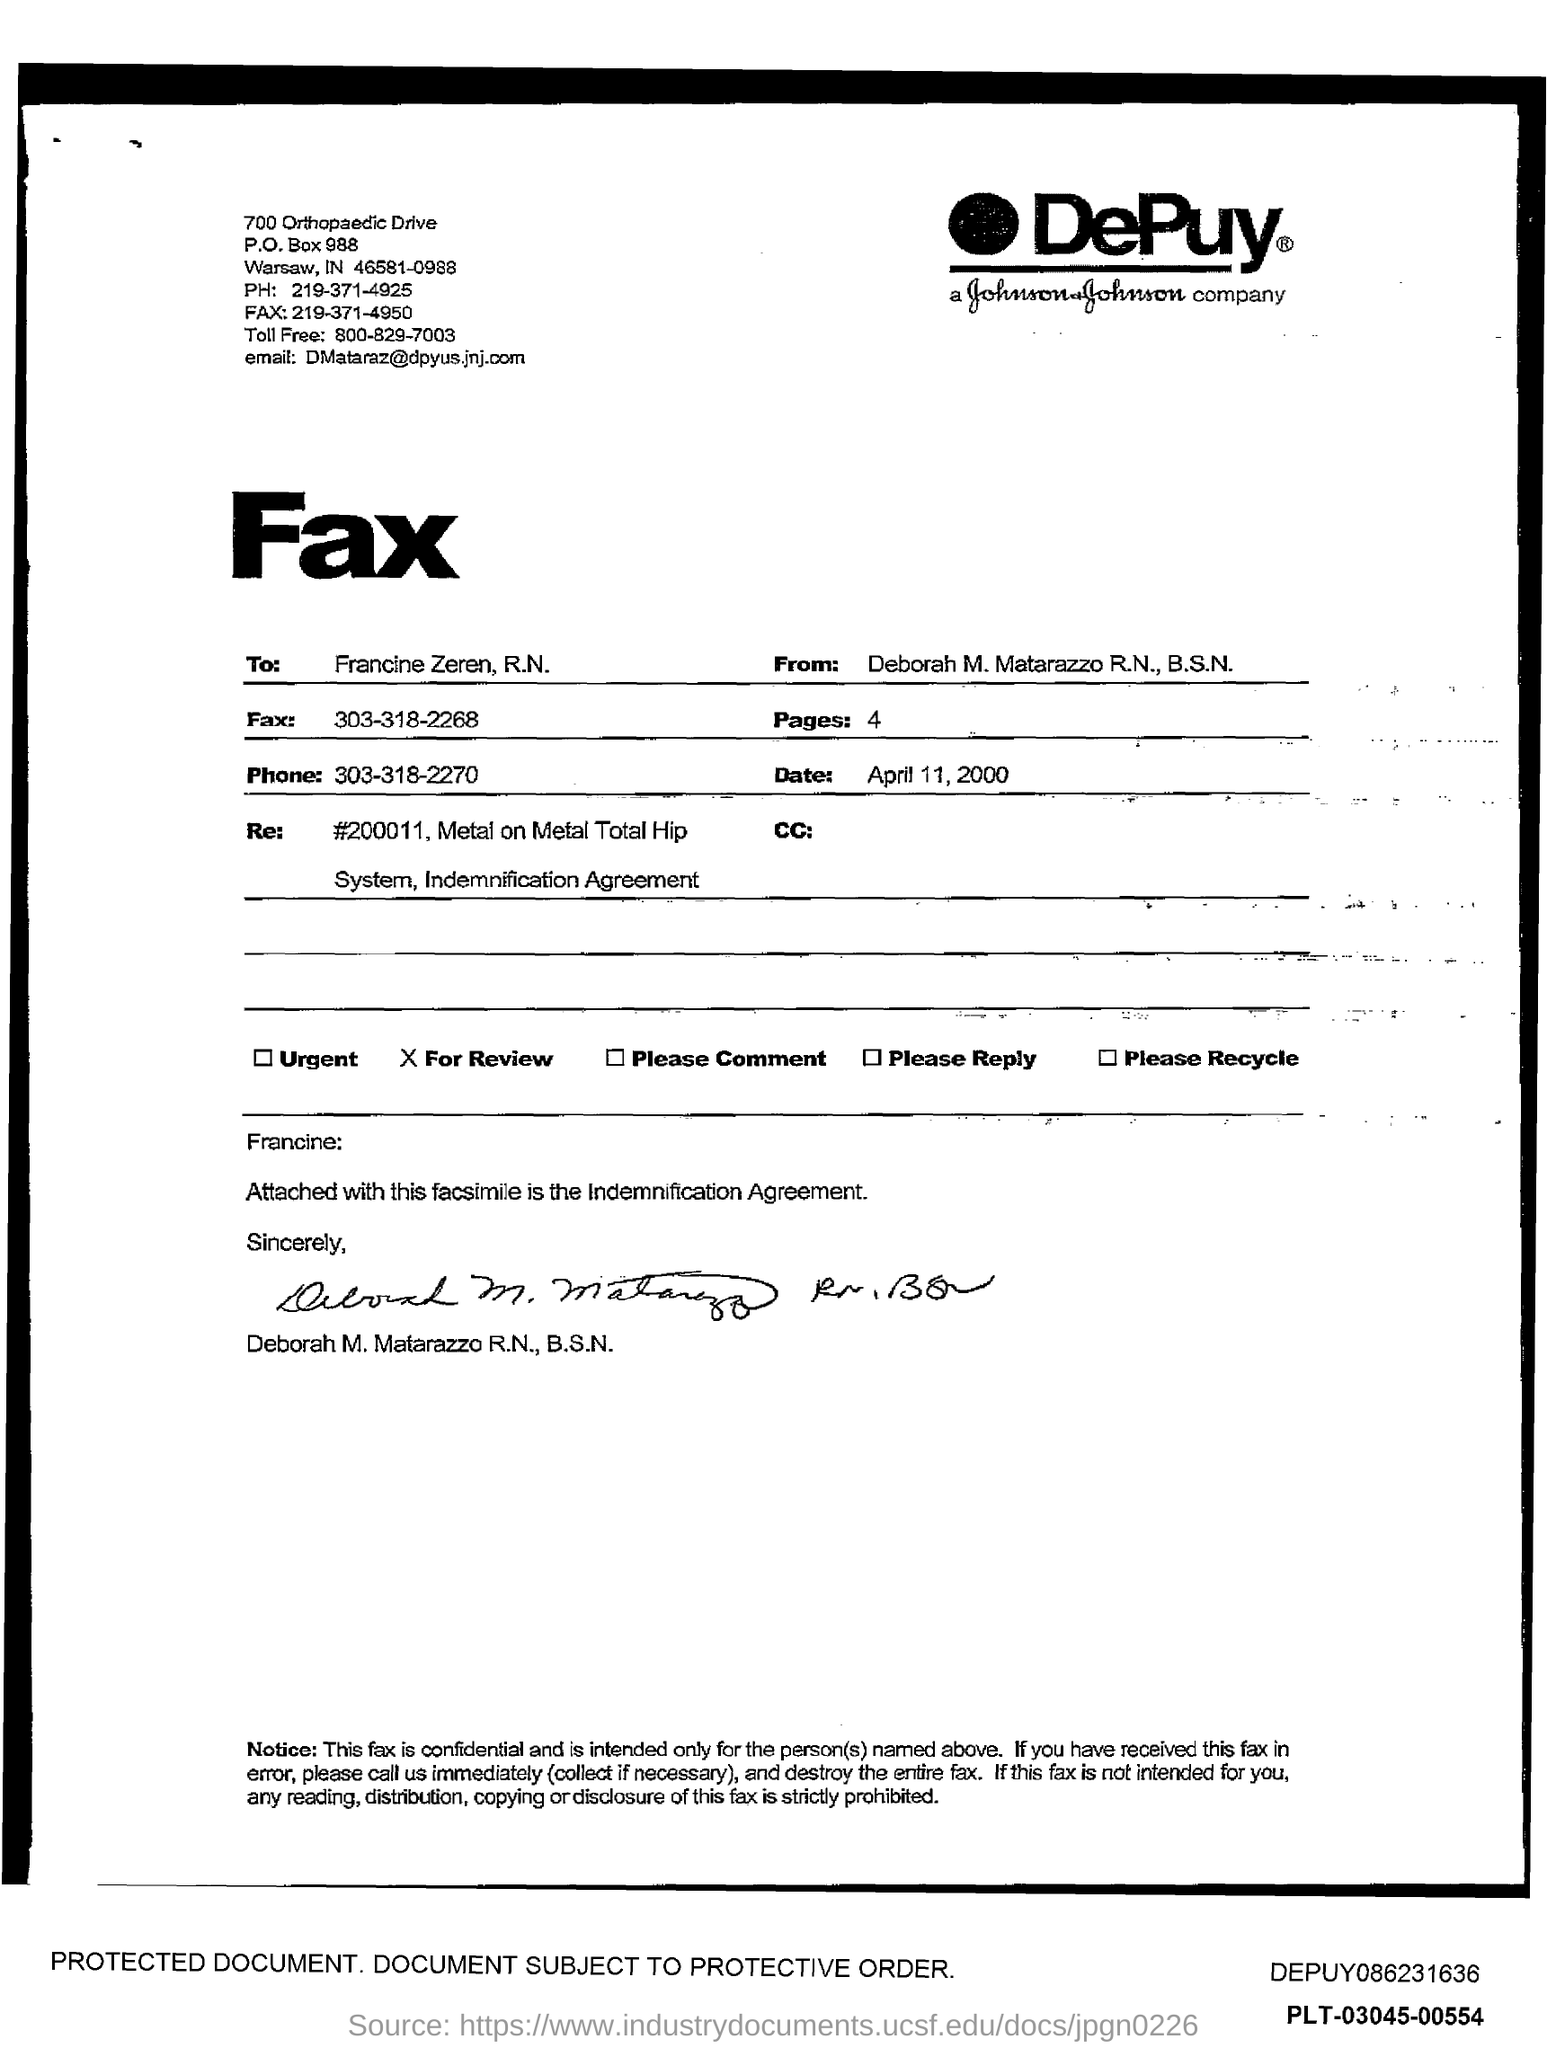To Whom is this Fax addressed to?
Provide a succinct answer. Francine Zeren, R.N. What is the Phone?
Give a very brief answer. 303-318-2270. What is the Fax?
Ensure brevity in your answer.  303-318-2268. How many pages?
Your answer should be compact. 4. 